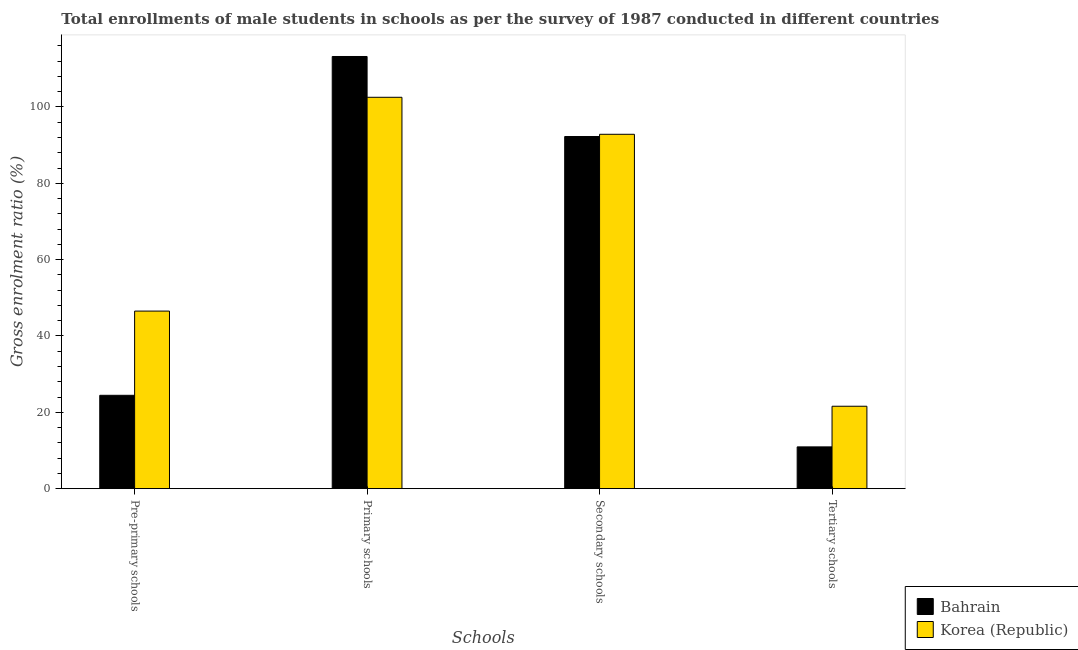How many groups of bars are there?
Ensure brevity in your answer.  4. Are the number of bars per tick equal to the number of legend labels?
Your response must be concise. Yes. Are the number of bars on each tick of the X-axis equal?
Provide a succinct answer. Yes. How many bars are there on the 2nd tick from the left?
Provide a short and direct response. 2. How many bars are there on the 2nd tick from the right?
Your answer should be very brief. 2. What is the label of the 3rd group of bars from the left?
Provide a short and direct response. Secondary schools. What is the gross enrolment ratio(male) in secondary schools in Bahrain?
Make the answer very short. 92.26. Across all countries, what is the maximum gross enrolment ratio(male) in tertiary schools?
Your answer should be compact. 21.59. Across all countries, what is the minimum gross enrolment ratio(male) in pre-primary schools?
Give a very brief answer. 24.46. In which country was the gross enrolment ratio(male) in primary schools maximum?
Provide a short and direct response. Bahrain. In which country was the gross enrolment ratio(male) in pre-primary schools minimum?
Keep it short and to the point. Bahrain. What is the total gross enrolment ratio(male) in secondary schools in the graph?
Provide a short and direct response. 185.11. What is the difference between the gross enrolment ratio(male) in pre-primary schools in Korea (Republic) and that in Bahrain?
Offer a terse response. 22.06. What is the difference between the gross enrolment ratio(male) in tertiary schools in Bahrain and the gross enrolment ratio(male) in secondary schools in Korea (Republic)?
Provide a succinct answer. -81.9. What is the average gross enrolment ratio(male) in secondary schools per country?
Give a very brief answer. 92.55. What is the difference between the gross enrolment ratio(male) in pre-primary schools and gross enrolment ratio(male) in primary schools in Korea (Republic)?
Offer a terse response. -56.01. In how many countries, is the gross enrolment ratio(male) in pre-primary schools greater than 76 %?
Offer a terse response. 0. What is the ratio of the gross enrolment ratio(male) in secondary schools in Korea (Republic) to that in Bahrain?
Your answer should be compact. 1.01. What is the difference between the highest and the second highest gross enrolment ratio(male) in secondary schools?
Make the answer very short. 0.58. What is the difference between the highest and the lowest gross enrolment ratio(male) in pre-primary schools?
Your response must be concise. 22.06. In how many countries, is the gross enrolment ratio(male) in primary schools greater than the average gross enrolment ratio(male) in primary schools taken over all countries?
Provide a short and direct response. 1. What does the 1st bar from the left in Pre-primary schools represents?
Your answer should be compact. Bahrain. What is the difference between two consecutive major ticks on the Y-axis?
Provide a succinct answer. 20. Are the values on the major ticks of Y-axis written in scientific E-notation?
Keep it short and to the point. No. Does the graph contain any zero values?
Provide a short and direct response. No. Does the graph contain grids?
Provide a short and direct response. No. What is the title of the graph?
Make the answer very short. Total enrollments of male students in schools as per the survey of 1987 conducted in different countries. What is the label or title of the X-axis?
Your answer should be compact. Schools. What is the label or title of the Y-axis?
Offer a terse response. Gross enrolment ratio (%). What is the Gross enrolment ratio (%) in Bahrain in Pre-primary schools?
Your response must be concise. 24.46. What is the Gross enrolment ratio (%) in Korea (Republic) in Pre-primary schools?
Your answer should be very brief. 46.52. What is the Gross enrolment ratio (%) of Bahrain in Primary schools?
Offer a terse response. 113.23. What is the Gross enrolment ratio (%) of Korea (Republic) in Primary schools?
Your response must be concise. 102.54. What is the Gross enrolment ratio (%) of Bahrain in Secondary schools?
Provide a succinct answer. 92.26. What is the Gross enrolment ratio (%) in Korea (Republic) in Secondary schools?
Keep it short and to the point. 92.85. What is the Gross enrolment ratio (%) of Bahrain in Tertiary schools?
Provide a succinct answer. 10.95. What is the Gross enrolment ratio (%) in Korea (Republic) in Tertiary schools?
Offer a very short reply. 21.59. Across all Schools, what is the maximum Gross enrolment ratio (%) in Bahrain?
Provide a short and direct response. 113.23. Across all Schools, what is the maximum Gross enrolment ratio (%) of Korea (Republic)?
Give a very brief answer. 102.54. Across all Schools, what is the minimum Gross enrolment ratio (%) in Bahrain?
Keep it short and to the point. 10.95. Across all Schools, what is the minimum Gross enrolment ratio (%) in Korea (Republic)?
Your response must be concise. 21.59. What is the total Gross enrolment ratio (%) in Bahrain in the graph?
Your response must be concise. 240.9. What is the total Gross enrolment ratio (%) of Korea (Republic) in the graph?
Offer a terse response. 263.5. What is the difference between the Gross enrolment ratio (%) of Bahrain in Pre-primary schools and that in Primary schools?
Provide a short and direct response. -88.77. What is the difference between the Gross enrolment ratio (%) of Korea (Republic) in Pre-primary schools and that in Primary schools?
Give a very brief answer. -56.01. What is the difference between the Gross enrolment ratio (%) of Bahrain in Pre-primary schools and that in Secondary schools?
Your answer should be compact. -67.8. What is the difference between the Gross enrolment ratio (%) of Korea (Republic) in Pre-primary schools and that in Secondary schools?
Your answer should be compact. -46.32. What is the difference between the Gross enrolment ratio (%) in Bahrain in Pre-primary schools and that in Tertiary schools?
Ensure brevity in your answer.  13.51. What is the difference between the Gross enrolment ratio (%) of Korea (Republic) in Pre-primary schools and that in Tertiary schools?
Keep it short and to the point. 24.93. What is the difference between the Gross enrolment ratio (%) in Bahrain in Primary schools and that in Secondary schools?
Provide a succinct answer. 20.97. What is the difference between the Gross enrolment ratio (%) of Korea (Republic) in Primary schools and that in Secondary schools?
Offer a very short reply. 9.69. What is the difference between the Gross enrolment ratio (%) of Bahrain in Primary schools and that in Tertiary schools?
Ensure brevity in your answer.  102.28. What is the difference between the Gross enrolment ratio (%) of Korea (Republic) in Primary schools and that in Tertiary schools?
Your answer should be compact. 80.94. What is the difference between the Gross enrolment ratio (%) in Bahrain in Secondary schools and that in Tertiary schools?
Your answer should be very brief. 81.31. What is the difference between the Gross enrolment ratio (%) of Korea (Republic) in Secondary schools and that in Tertiary schools?
Make the answer very short. 71.25. What is the difference between the Gross enrolment ratio (%) in Bahrain in Pre-primary schools and the Gross enrolment ratio (%) in Korea (Republic) in Primary schools?
Ensure brevity in your answer.  -78.08. What is the difference between the Gross enrolment ratio (%) of Bahrain in Pre-primary schools and the Gross enrolment ratio (%) of Korea (Republic) in Secondary schools?
Offer a very short reply. -68.38. What is the difference between the Gross enrolment ratio (%) of Bahrain in Pre-primary schools and the Gross enrolment ratio (%) of Korea (Republic) in Tertiary schools?
Your response must be concise. 2.87. What is the difference between the Gross enrolment ratio (%) of Bahrain in Primary schools and the Gross enrolment ratio (%) of Korea (Republic) in Secondary schools?
Your answer should be very brief. 20.38. What is the difference between the Gross enrolment ratio (%) of Bahrain in Primary schools and the Gross enrolment ratio (%) of Korea (Republic) in Tertiary schools?
Offer a terse response. 91.63. What is the difference between the Gross enrolment ratio (%) in Bahrain in Secondary schools and the Gross enrolment ratio (%) in Korea (Republic) in Tertiary schools?
Your response must be concise. 70.67. What is the average Gross enrolment ratio (%) in Bahrain per Schools?
Provide a short and direct response. 60.23. What is the average Gross enrolment ratio (%) in Korea (Republic) per Schools?
Your response must be concise. 65.88. What is the difference between the Gross enrolment ratio (%) in Bahrain and Gross enrolment ratio (%) in Korea (Republic) in Pre-primary schools?
Your answer should be very brief. -22.06. What is the difference between the Gross enrolment ratio (%) in Bahrain and Gross enrolment ratio (%) in Korea (Republic) in Primary schools?
Your answer should be very brief. 10.69. What is the difference between the Gross enrolment ratio (%) in Bahrain and Gross enrolment ratio (%) in Korea (Republic) in Secondary schools?
Provide a short and direct response. -0.58. What is the difference between the Gross enrolment ratio (%) of Bahrain and Gross enrolment ratio (%) of Korea (Republic) in Tertiary schools?
Your answer should be compact. -10.65. What is the ratio of the Gross enrolment ratio (%) in Bahrain in Pre-primary schools to that in Primary schools?
Your answer should be very brief. 0.22. What is the ratio of the Gross enrolment ratio (%) in Korea (Republic) in Pre-primary schools to that in Primary schools?
Make the answer very short. 0.45. What is the ratio of the Gross enrolment ratio (%) of Bahrain in Pre-primary schools to that in Secondary schools?
Offer a terse response. 0.27. What is the ratio of the Gross enrolment ratio (%) of Korea (Republic) in Pre-primary schools to that in Secondary schools?
Provide a short and direct response. 0.5. What is the ratio of the Gross enrolment ratio (%) of Bahrain in Pre-primary schools to that in Tertiary schools?
Offer a terse response. 2.23. What is the ratio of the Gross enrolment ratio (%) of Korea (Republic) in Pre-primary schools to that in Tertiary schools?
Give a very brief answer. 2.15. What is the ratio of the Gross enrolment ratio (%) of Bahrain in Primary schools to that in Secondary schools?
Your answer should be very brief. 1.23. What is the ratio of the Gross enrolment ratio (%) in Korea (Republic) in Primary schools to that in Secondary schools?
Offer a terse response. 1.1. What is the ratio of the Gross enrolment ratio (%) of Bahrain in Primary schools to that in Tertiary schools?
Ensure brevity in your answer.  10.34. What is the ratio of the Gross enrolment ratio (%) in Korea (Republic) in Primary schools to that in Tertiary schools?
Your answer should be very brief. 4.75. What is the ratio of the Gross enrolment ratio (%) in Bahrain in Secondary schools to that in Tertiary schools?
Your response must be concise. 8.43. What is the ratio of the Gross enrolment ratio (%) of Korea (Republic) in Secondary schools to that in Tertiary schools?
Provide a short and direct response. 4.3. What is the difference between the highest and the second highest Gross enrolment ratio (%) of Bahrain?
Give a very brief answer. 20.97. What is the difference between the highest and the second highest Gross enrolment ratio (%) of Korea (Republic)?
Ensure brevity in your answer.  9.69. What is the difference between the highest and the lowest Gross enrolment ratio (%) of Bahrain?
Give a very brief answer. 102.28. What is the difference between the highest and the lowest Gross enrolment ratio (%) in Korea (Republic)?
Give a very brief answer. 80.94. 